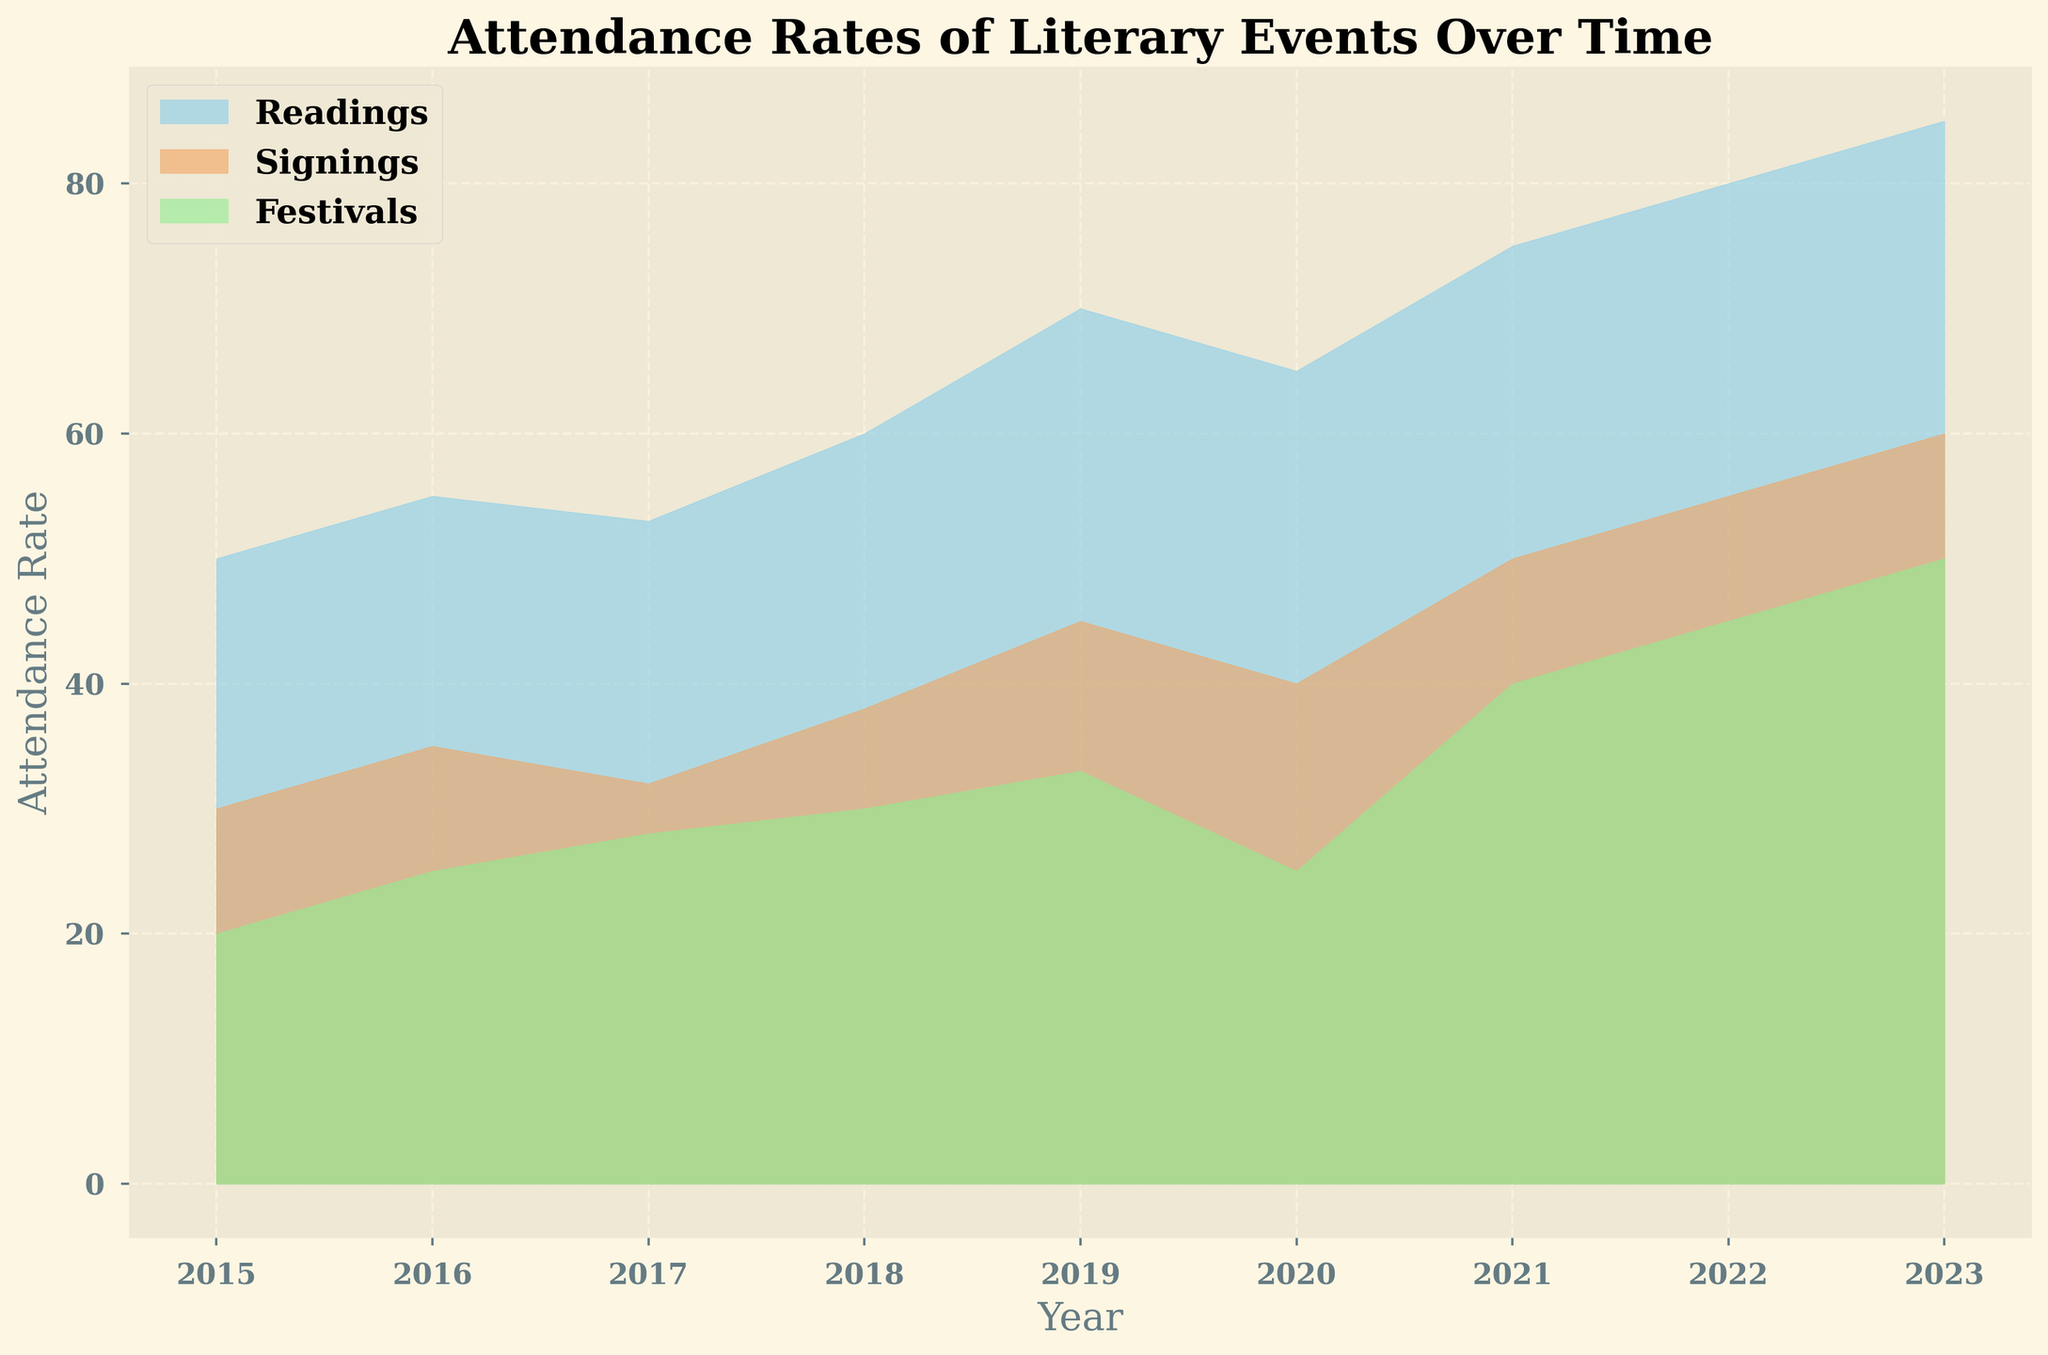What is the attendance rate for Readings in 2020? Locate the year 2020 on the x-axis and follow it up to the blue area representing Readings. The top edge of the area for Readings intersects with the y-axis value of 65.
Answer: 65 Which event type had the highest attendance rate in 2023? Locate the year 2023 on the x-axis and observe the heights of the different colored areas. The blue area representing Readings is the highest, followed by the orange area (Signings) and the green area (Festivals). Therefore, Readings had the highest attendance rate.
Answer: Readings What is the difference in attendance rates between Festivals and Signings in 2019? Locate the year 2019 on the x-axis and compare the heights of the green area (Festivals: 33) and the orange area (Signings: 45). Subtract the attendance rate of Festivals from that of Signings (45 - 33).
Answer: 12 How did the attendance rates for Readings change from 2015 to 2023? Identify the attendance rates for Readings in both 2015 (50) and 2023 (85) from the blue area. Calculate the change by subtracting the 2015 value from the 2023 value (85 - 50).
Answer: Increased by 35 What is the average attendance rate for Readings over the given years? Sum the attendance rates for Readings from 2015 to 2023 (50 + 55 + 53 + 60 + 70 + 65 + 75 + 80 + 85 = 593). Divide by the number of years (593 / 9).
Answer: 65.89 Compare the trends of attendance rates for Readings and Signings from 2018 to 2020. Locate the years 2018 to 2020 on the x-axis and observe the blue and orange areas. For Readings, the trend is 60 (2018) -> 70 (2019) -> 65 (2020), which shows an increase followed by a decrease. For Signings, the trend is 38 (2018) -> 45 (2019) -> 40 (2020), which also shows an increase followed by a decrease. Both event types show similar patterns in these years.
Answer: Similar trend of increasing then decreasing By how much did the attendance rate for Festivals increase from 2015 to 2023? Identify the attendance rates for Festivals in 2015 (20) and 2023 (50). Calculate the increase by subtracting the 2015 value from the 2023 value (50 - 20).
Answer: Increased by 30 What year did Readings surpass 70 attendance rate for the first time? Trace the blue area representing Readings. The attendance rate surpasses 70 for the first time in 2019, indicated by the height of the blue area.
Answer: 2019 